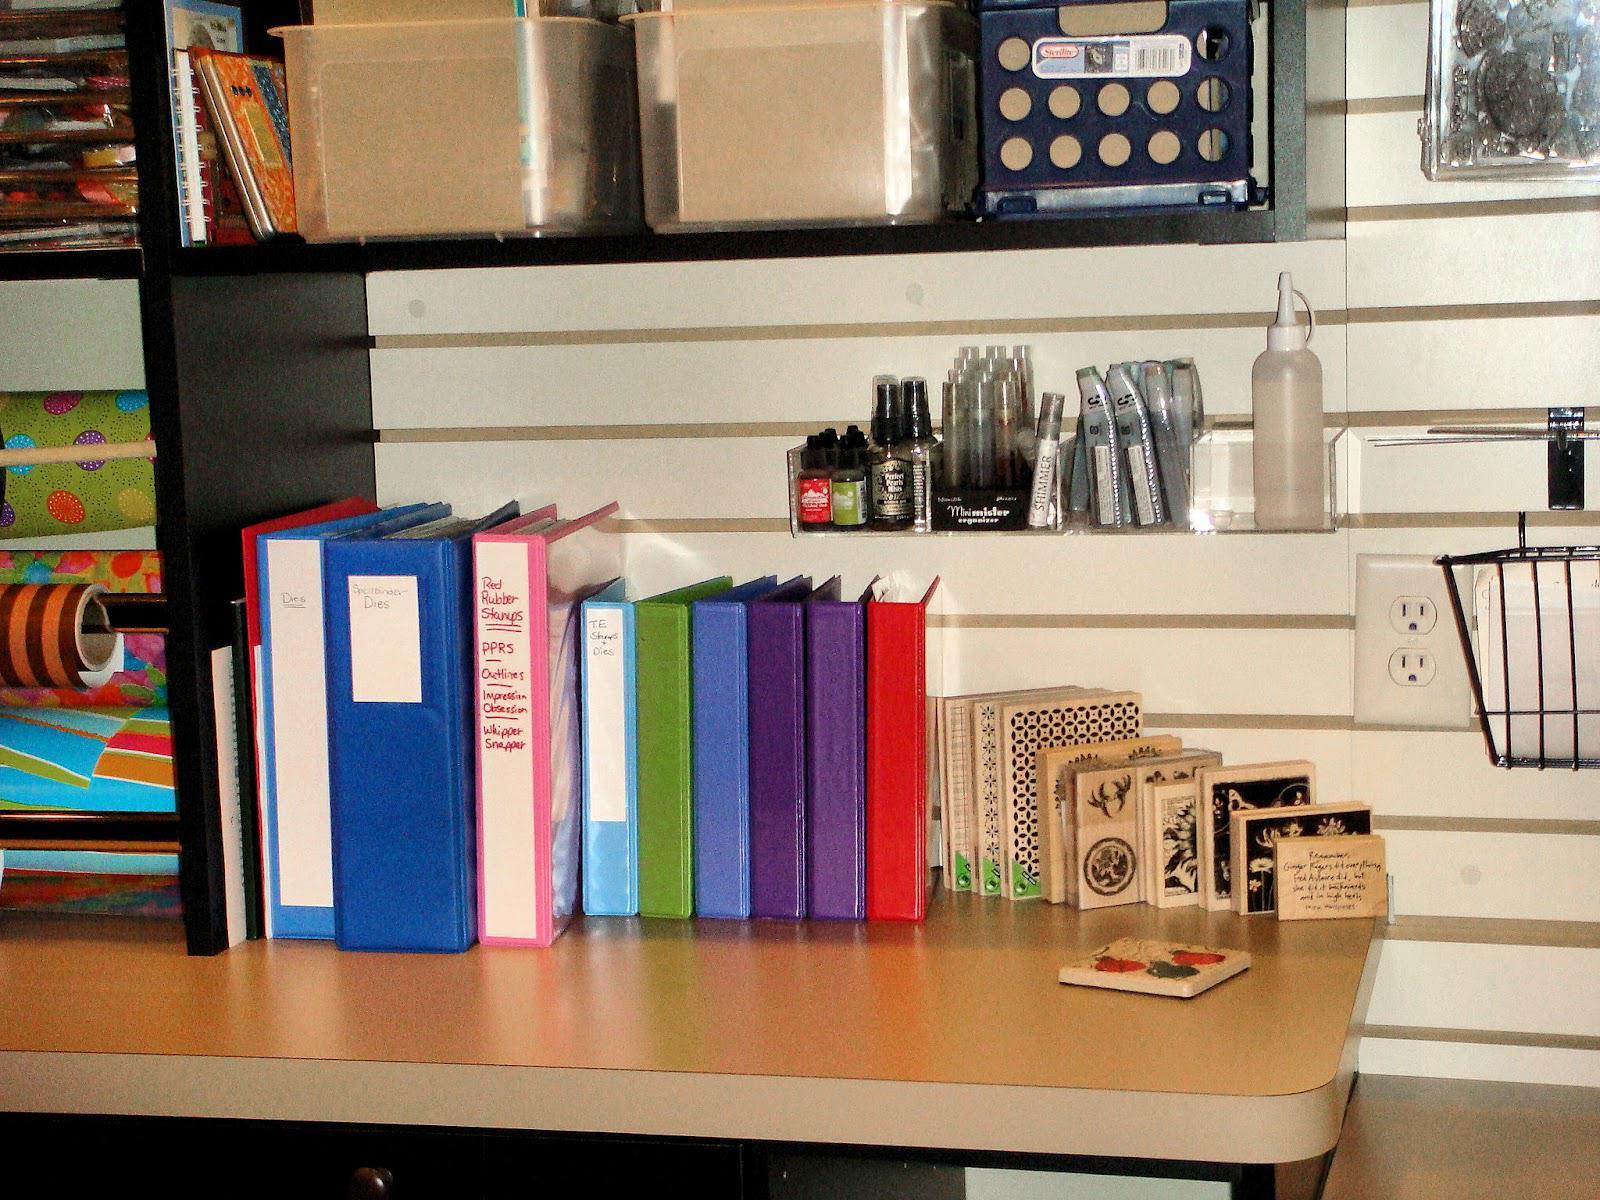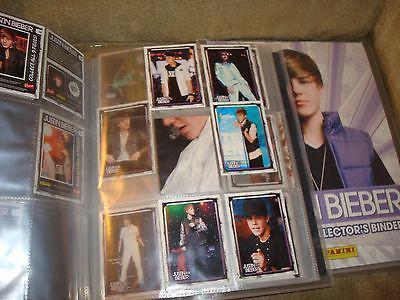The first image is the image on the left, the second image is the image on the right. For the images displayed, is the sentence "Collector cards arranged in plastic pockets of notebook pages are shown in one image." factually correct? Answer yes or no. Yes. 